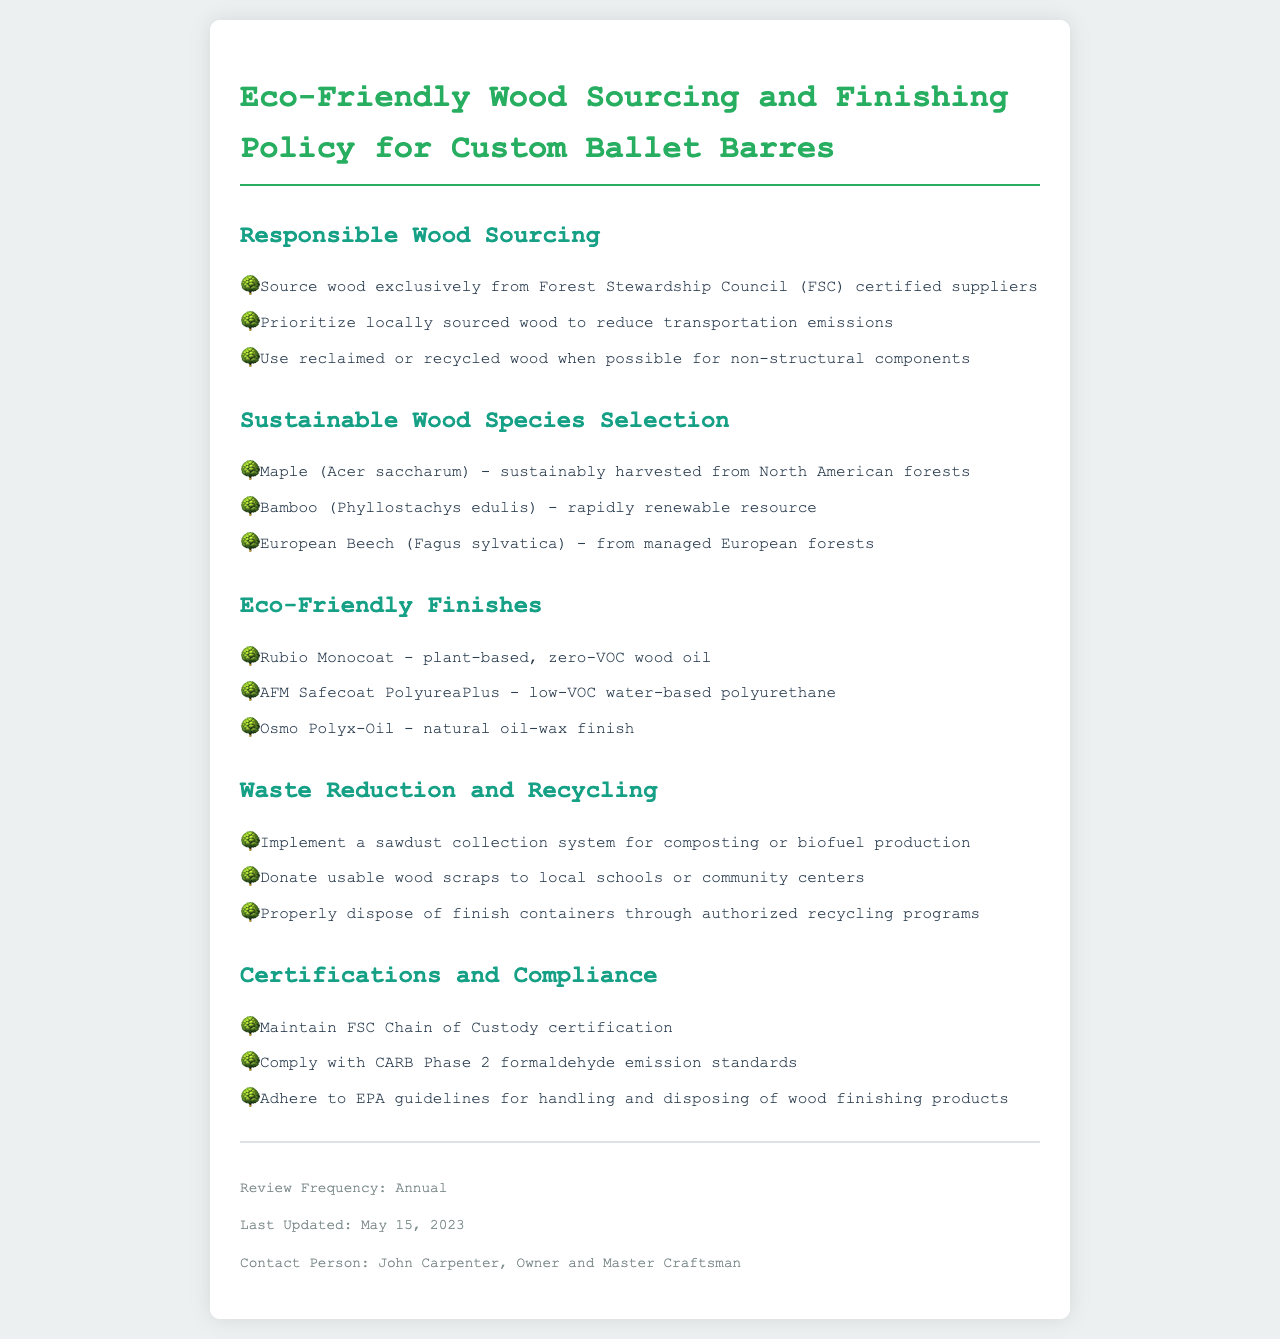what is the policy title? The title is found at the top of the document.
Answer: Eco-Friendly Wood Sourcing and Finishing Policy for Custom Ballet Barres who is the contact person for the policy? The contact person's name is mentioned in the footer of the document.
Answer: John Carpenter what is the last updated date of the policy? The last updated date is provided in the footer section.
Answer: May 15, 2023 which certification is maintained for wood sourcing? The relevant certification for wood sourcing is listed under certifications.
Answer: FSC Chain of Custody what wood species is prioritized from the North American forests? The specific wood species prioritized is mentioned in the sustainable wood species section.
Answer: Maple (Acer saccharum) what type of finish is zero-VOC? This type of finish is highlighted under the eco-friendly finishes section.
Answer: Rubio Monocoat how often is the policy reviewed? The review frequency is mentioned in the footer of the document.
Answer: Annual what is done with usable wood scraps? The action taken with usable wood scraps is included in the waste reduction section.
Answer: Donate to local schools or community centers what standard must be complied with regarding formaldehyde emissions? This standard is specifically listed under certifications and compliance.
Answer: CARB Phase 2 